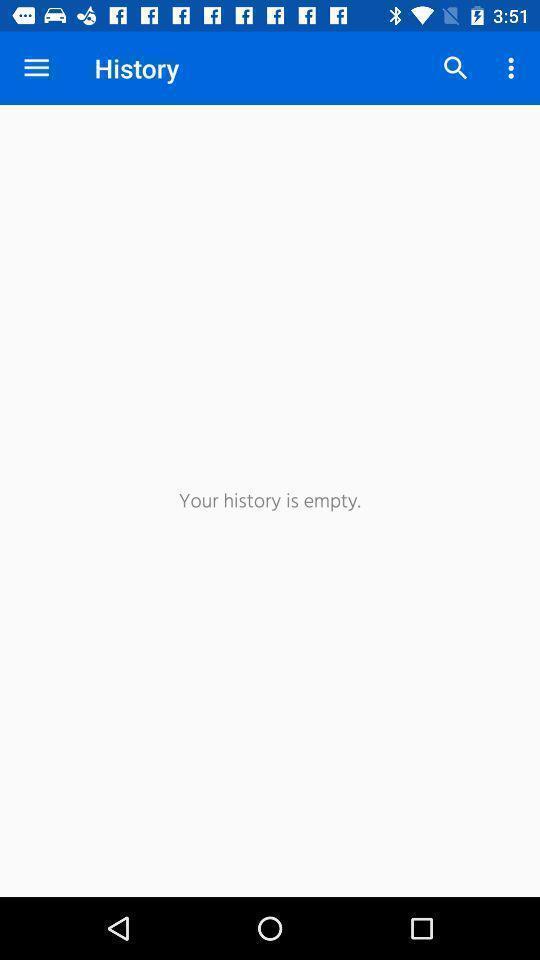What can you discern from this picture? Screen shows history details. 